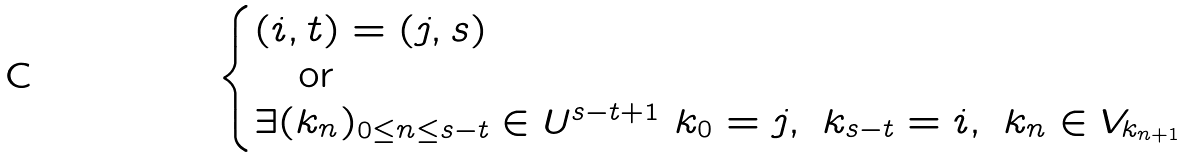<formula> <loc_0><loc_0><loc_500><loc_500>\begin{cases} ( i , t ) = ( j , s ) \\ \quad \text {or} \\ \exists ( k _ { n } ) _ { 0 \leq n \leq s - t } \in U ^ { s - t + 1 } \ k _ { 0 } = j , \ k _ { s - t } = i , \ k _ { n } \in V _ { k _ { n + 1 } } \\ \end{cases}</formula> 